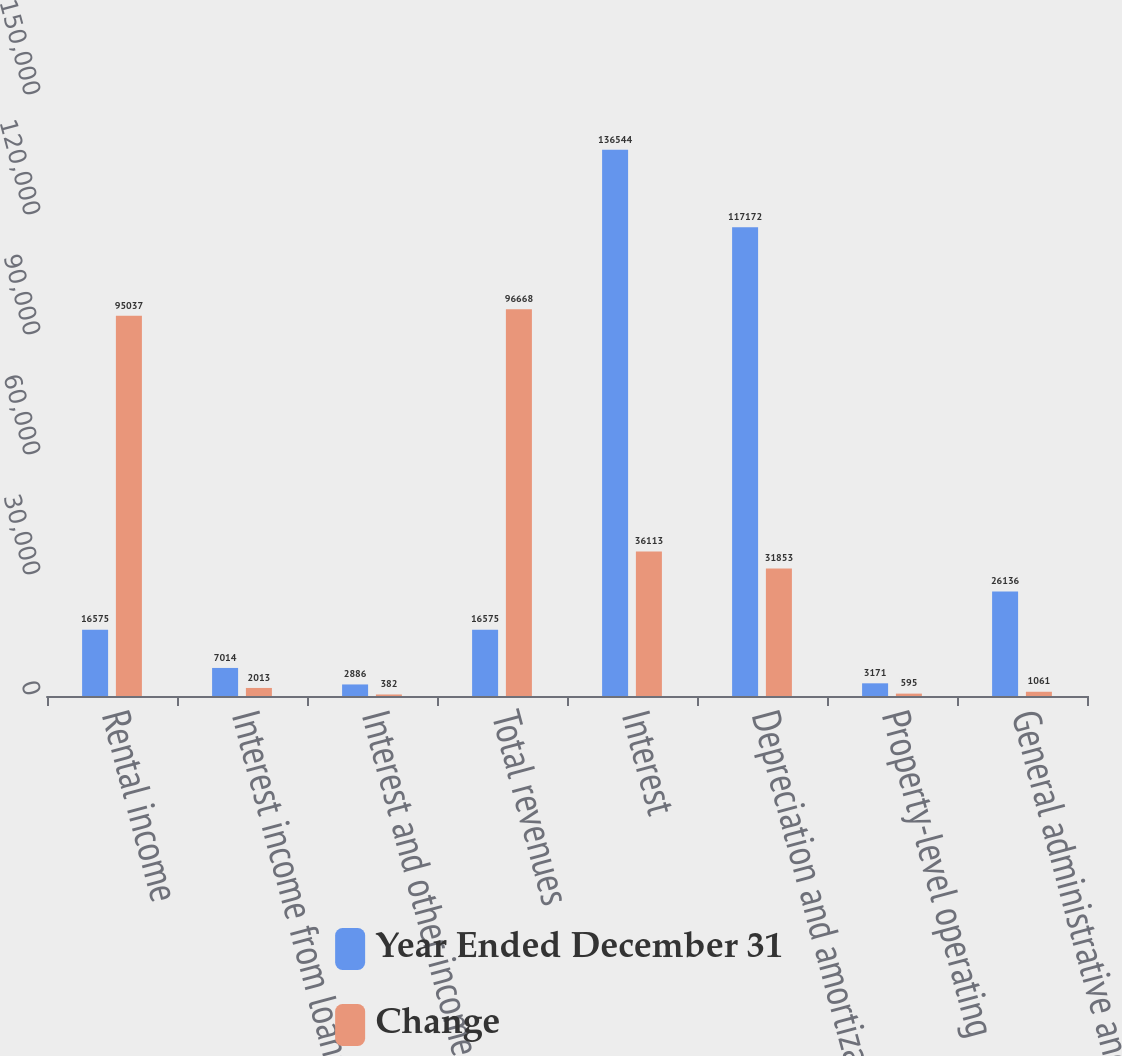Convert chart. <chart><loc_0><loc_0><loc_500><loc_500><stacked_bar_chart><ecel><fcel>Rental income<fcel>Interest income from loans<fcel>Interest and other income<fcel>Total revenues<fcel>Interest<fcel>Depreciation and amortization<fcel>Property-level operating<fcel>General administrative and<nl><fcel>Year Ended December 31<fcel>16575<fcel>7014<fcel>2886<fcel>16575<fcel>136544<fcel>117172<fcel>3171<fcel>26136<nl><fcel>Change<fcel>95037<fcel>2013<fcel>382<fcel>96668<fcel>36113<fcel>31853<fcel>595<fcel>1061<nl></chart> 